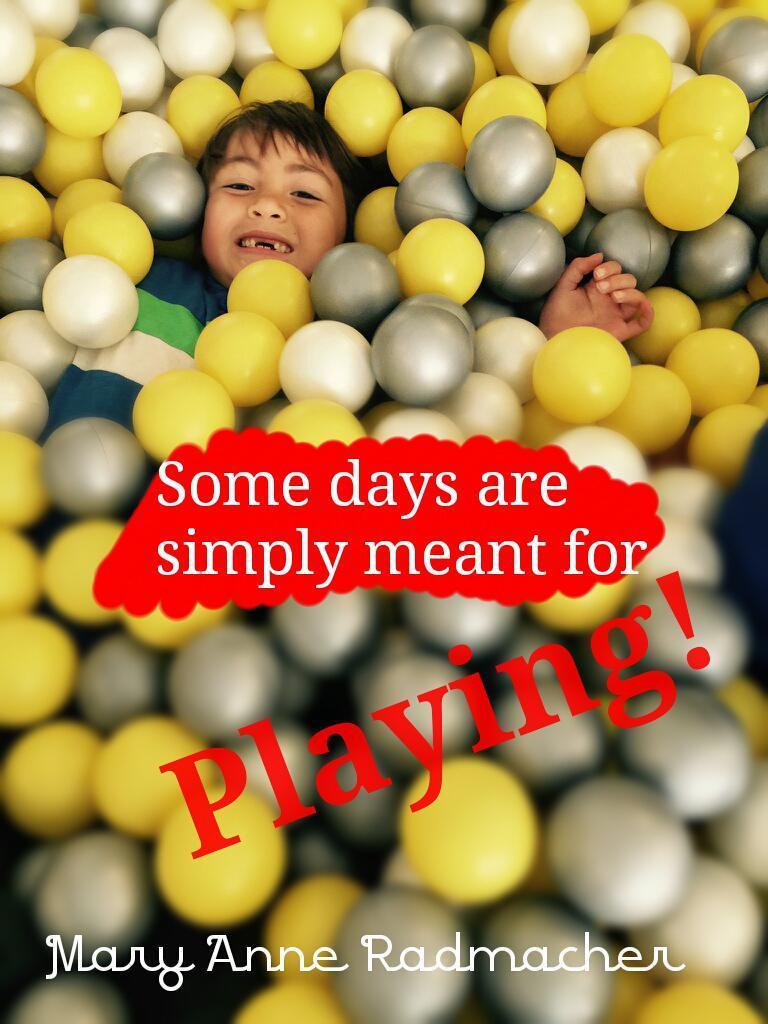Describe this image in one or two sentences. In this image we can see a boy wearing dress and group of balls around him. In the foreground we can see some text. 